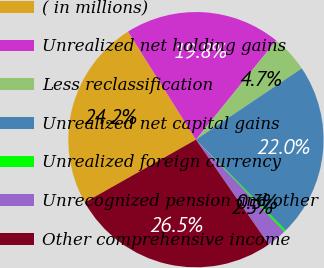Convert chart. <chart><loc_0><loc_0><loc_500><loc_500><pie_chart><fcel>( in millions)<fcel>Unrealized net holding gains<fcel>Less reclassification<fcel>Unrealized net capital gains<fcel>Unrealized foreign currency<fcel>Unrecognized pension and other<fcel>Other comprehensive income<nl><fcel>24.25%<fcel>19.76%<fcel>4.74%<fcel>22.0%<fcel>0.26%<fcel>2.5%<fcel>26.49%<nl></chart> 